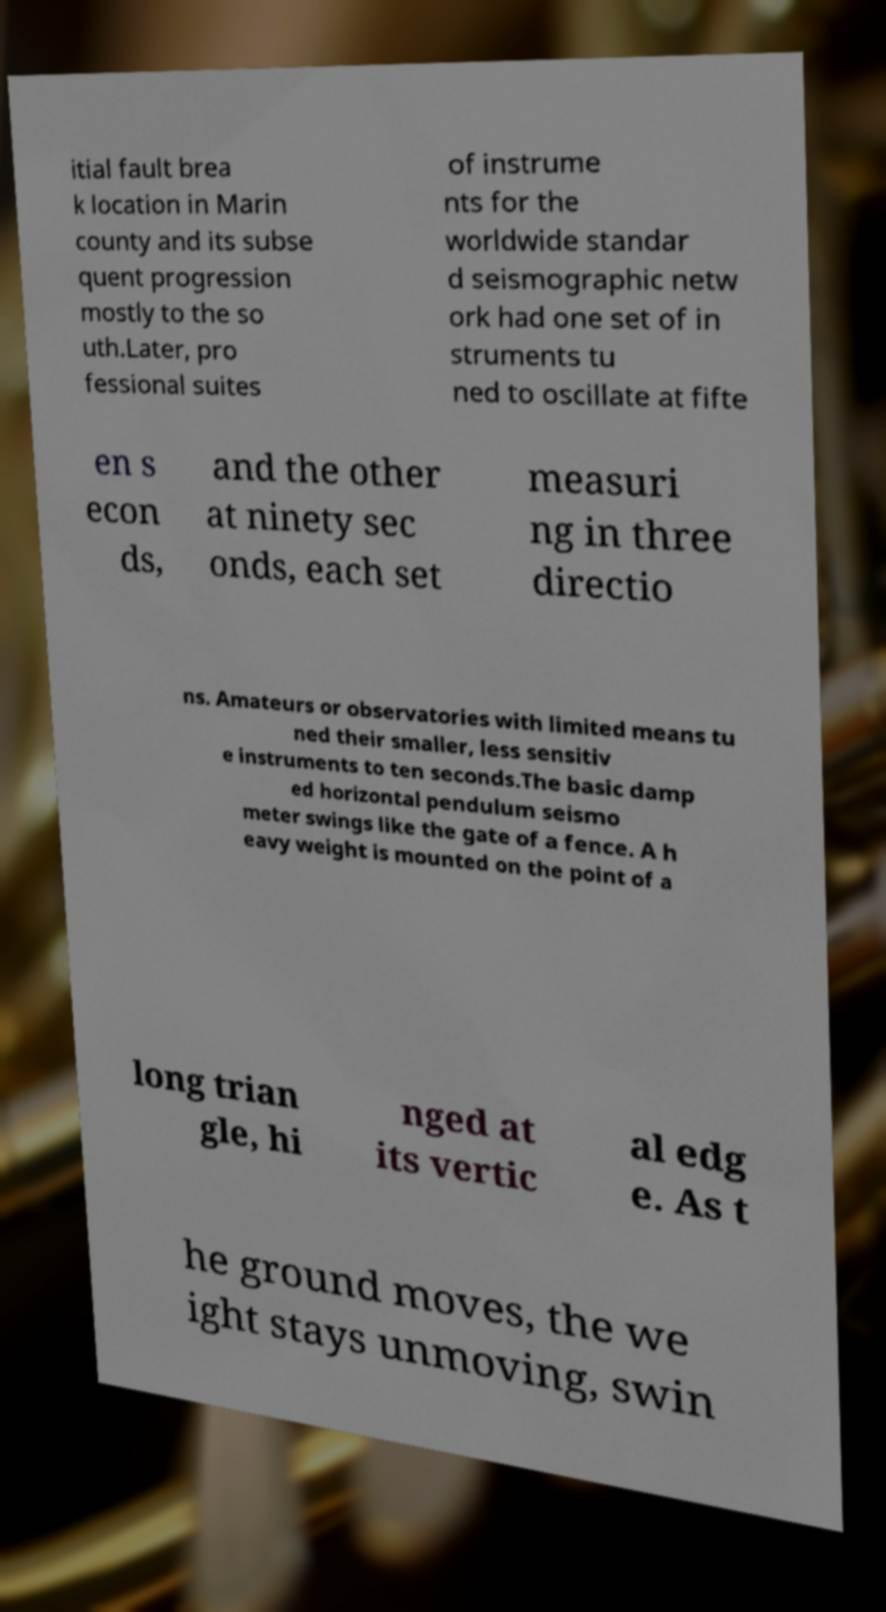For documentation purposes, I need the text within this image transcribed. Could you provide that? itial fault brea k location in Marin county and its subse quent progression mostly to the so uth.Later, pro fessional suites of instrume nts for the worldwide standar d seismographic netw ork had one set of in struments tu ned to oscillate at fifte en s econ ds, and the other at ninety sec onds, each set measuri ng in three directio ns. Amateurs or observatories with limited means tu ned their smaller, less sensitiv e instruments to ten seconds.The basic damp ed horizontal pendulum seismo meter swings like the gate of a fence. A h eavy weight is mounted on the point of a long trian gle, hi nged at its vertic al edg e. As t he ground moves, the we ight stays unmoving, swin 